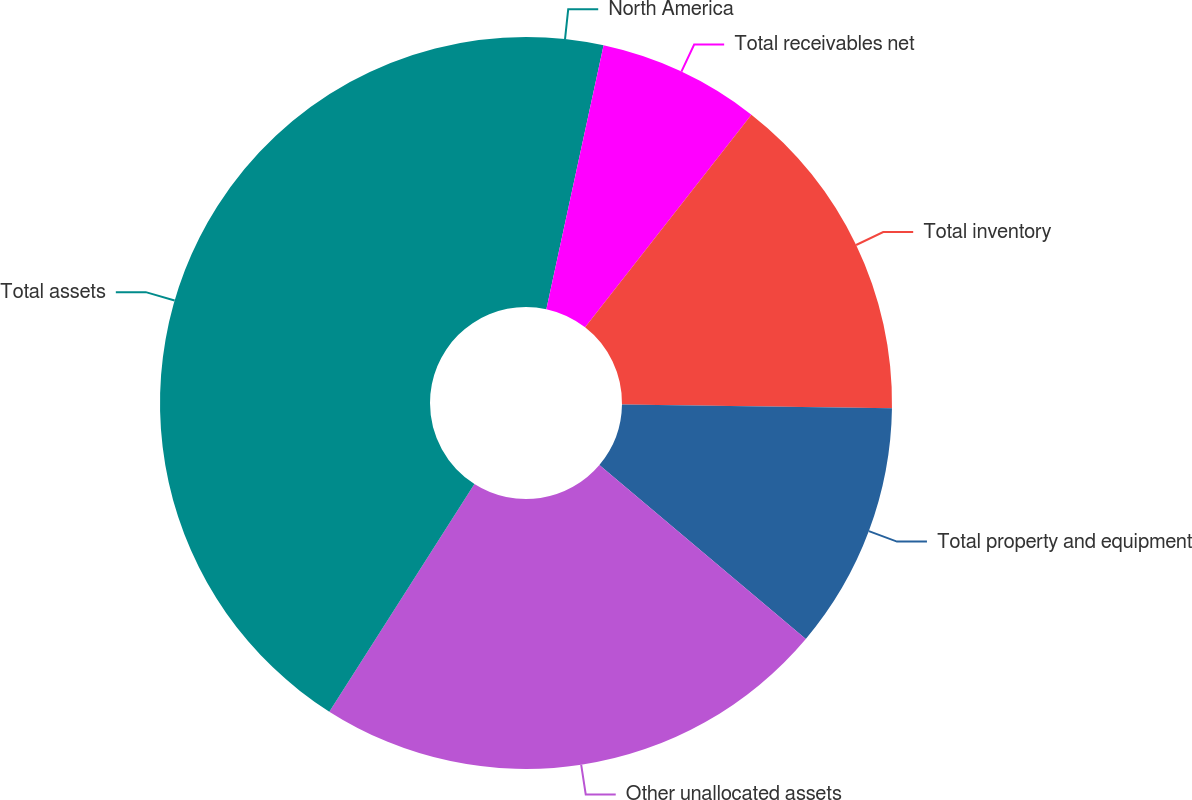Convert chart to OTSL. <chart><loc_0><loc_0><loc_500><loc_500><pie_chart><fcel>North America<fcel>Total receivables net<fcel>Total inventory<fcel>Total property and equipment<fcel>Other unallocated assets<fcel>Total assets<nl><fcel>3.4%<fcel>7.16%<fcel>14.67%<fcel>10.92%<fcel>22.88%<fcel>40.97%<nl></chart> 